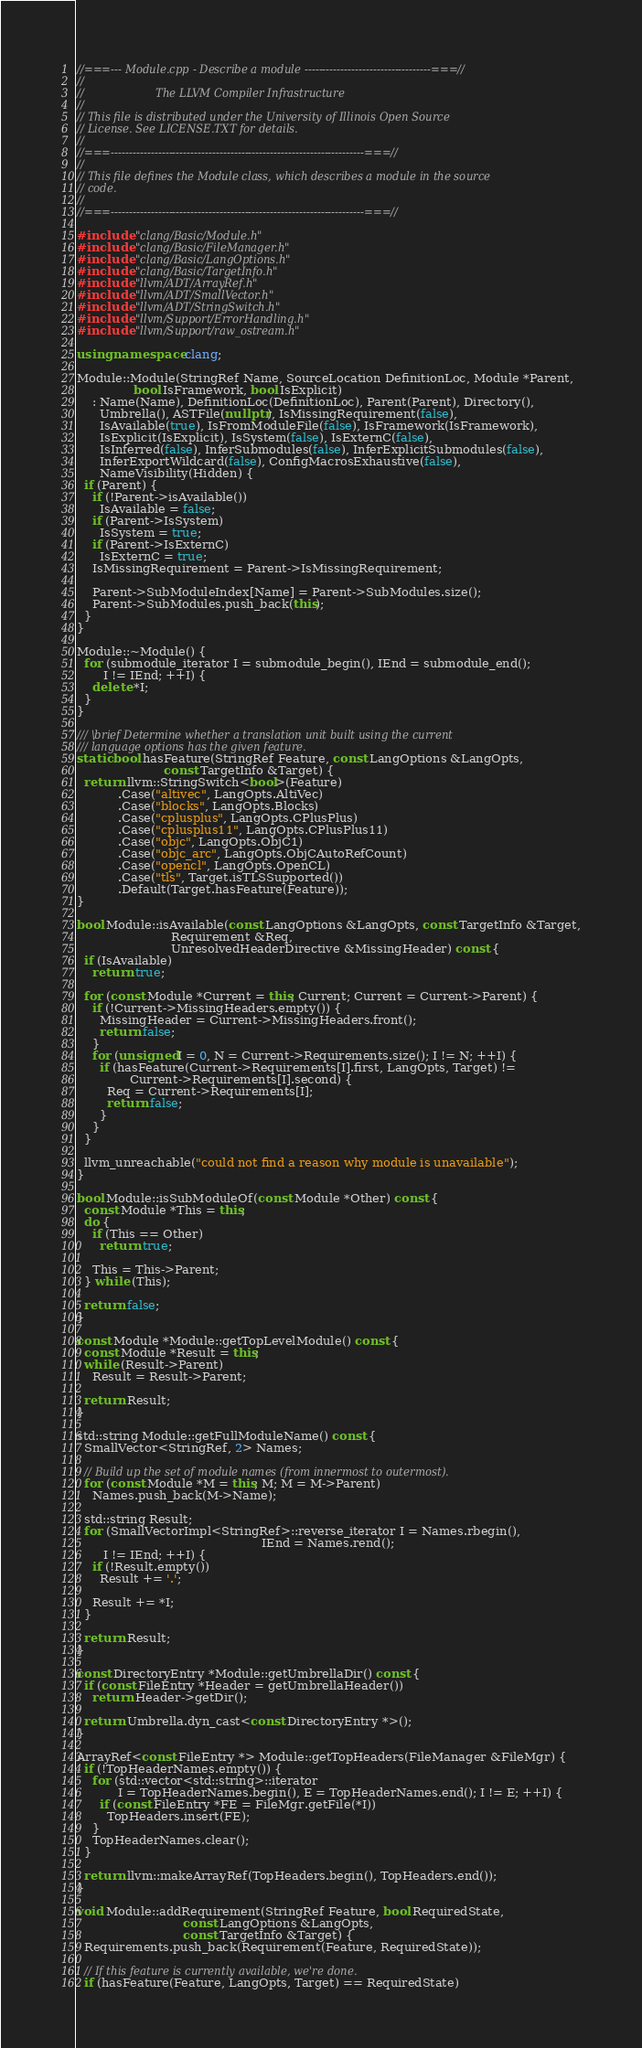<code> <loc_0><loc_0><loc_500><loc_500><_C++_>//===--- Module.cpp - Describe a module -----------------------------------===//
//
//                     The LLVM Compiler Infrastructure
//
// This file is distributed under the University of Illinois Open Source
// License. See LICENSE.TXT for details.
//
//===----------------------------------------------------------------------===//
//
// This file defines the Module class, which describes a module in the source
// code.
//
//===----------------------------------------------------------------------===//

#include "clang/Basic/Module.h"
#include "clang/Basic/FileManager.h"
#include "clang/Basic/LangOptions.h"
#include "clang/Basic/TargetInfo.h"
#include "llvm/ADT/ArrayRef.h"
#include "llvm/ADT/SmallVector.h"
#include "llvm/ADT/StringSwitch.h"
#include "llvm/Support/ErrorHandling.h"
#include "llvm/Support/raw_ostream.h"

using namespace clang;

Module::Module(StringRef Name, SourceLocation DefinitionLoc, Module *Parent,
               bool IsFramework, bool IsExplicit)
    : Name(Name), DefinitionLoc(DefinitionLoc), Parent(Parent), Directory(),
      Umbrella(), ASTFile(nullptr), IsMissingRequirement(false),
      IsAvailable(true), IsFromModuleFile(false), IsFramework(IsFramework),
      IsExplicit(IsExplicit), IsSystem(false), IsExternC(false),
      IsInferred(false), InferSubmodules(false), InferExplicitSubmodules(false),
      InferExportWildcard(false), ConfigMacrosExhaustive(false),
      NameVisibility(Hidden) {
  if (Parent) {
    if (!Parent->isAvailable())
      IsAvailable = false;
    if (Parent->IsSystem)
      IsSystem = true;
    if (Parent->IsExternC)
      IsExternC = true;
    IsMissingRequirement = Parent->IsMissingRequirement;
    
    Parent->SubModuleIndex[Name] = Parent->SubModules.size();
    Parent->SubModules.push_back(this);
  }
}

Module::~Module() {
  for (submodule_iterator I = submodule_begin(), IEnd = submodule_end();
       I != IEnd; ++I) {
    delete *I;
  }
}

/// \brief Determine whether a translation unit built using the current
/// language options has the given feature.
static bool hasFeature(StringRef Feature, const LangOptions &LangOpts,
                       const TargetInfo &Target) {
  return llvm::StringSwitch<bool>(Feature)
           .Case("altivec", LangOpts.AltiVec)
           .Case("blocks", LangOpts.Blocks)
           .Case("cplusplus", LangOpts.CPlusPlus)
           .Case("cplusplus11", LangOpts.CPlusPlus11)
           .Case("objc", LangOpts.ObjC1)
           .Case("objc_arc", LangOpts.ObjCAutoRefCount)
           .Case("opencl", LangOpts.OpenCL)
           .Case("tls", Target.isTLSSupported())
           .Default(Target.hasFeature(Feature));
}

bool Module::isAvailable(const LangOptions &LangOpts, const TargetInfo &Target,
                         Requirement &Req,
                         UnresolvedHeaderDirective &MissingHeader) const {
  if (IsAvailable)
    return true;

  for (const Module *Current = this; Current; Current = Current->Parent) {
    if (!Current->MissingHeaders.empty()) {
      MissingHeader = Current->MissingHeaders.front();
      return false;
    }
    for (unsigned I = 0, N = Current->Requirements.size(); I != N; ++I) {
      if (hasFeature(Current->Requirements[I].first, LangOpts, Target) !=
              Current->Requirements[I].second) {
        Req = Current->Requirements[I];
        return false;
      }
    }
  }

  llvm_unreachable("could not find a reason why module is unavailable");
}

bool Module::isSubModuleOf(const Module *Other) const {
  const Module *This = this;
  do {
    if (This == Other)
      return true;
    
    This = This->Parent;
  } while (This);
  
  return false;
}

const Module *Module::getTopLevelModule() const {
  const Module *Result = this;
  while (Result->Parent)
    Result = Result->Parent;
  
  return Result;
}

std::string Module::getFullModuleName() const {
  SmallVector<StringRef, 2> Names;
  
  // Build up the set of module names (from innermost to outermost).
  for (const Module *M = this; M; M = M->Parent)
    Names.push_back(M->Name);
  
  std::string Result;
  for (SmallVectorImpl<StringRef>::reverse_iterator I = Names.rbegin(),
                                                 IEnd = Names.rend();
       I != IEnd; ++I) {
    if (!Result.empty())
      Result += '.';
    
    Result += *I;
  }
  
  return Result;
}

const DirectoryEntry *Module::getUmbrellaDir() const {
  if (const FileEntry *Header = getUmbrellaHeader())
    return Header->getDir();
  
  return Umbrella.dyn_cast<const DirectoryEntry *>();
}

ArrayRef<const FileEntry *> Module::getTopHeaders(FileManager &FileMgr) {
  if (!TopHeaderNames.empty()) {
    for (std::vector<std::string>::iterator
           I = TopHeaderNames.begin(), E = TopHeaderNames.end(); I != E; ++I) {
      if (const FileEntry *FE = FileMgr.getFile(*I))
        TopHeaders.insert(FE);
    }
    TopHeaderNames.clear();
  }

  return llvm::makeArrayRef(TopHeaders.begin(), TopHeaders.end());
}

void Module::addRequirement(StringRef Feature, bool RequiredState,
                            const LangOptions &LangOpts,
                            const TargetInfo &Target) {
  Requirements.push_back(Requirement(Feature, RequiredState));

  // If this feature is currently available, we're done.
  if (hasFeature(Feature, LangOpts, Target) == RequiredState)</code> 